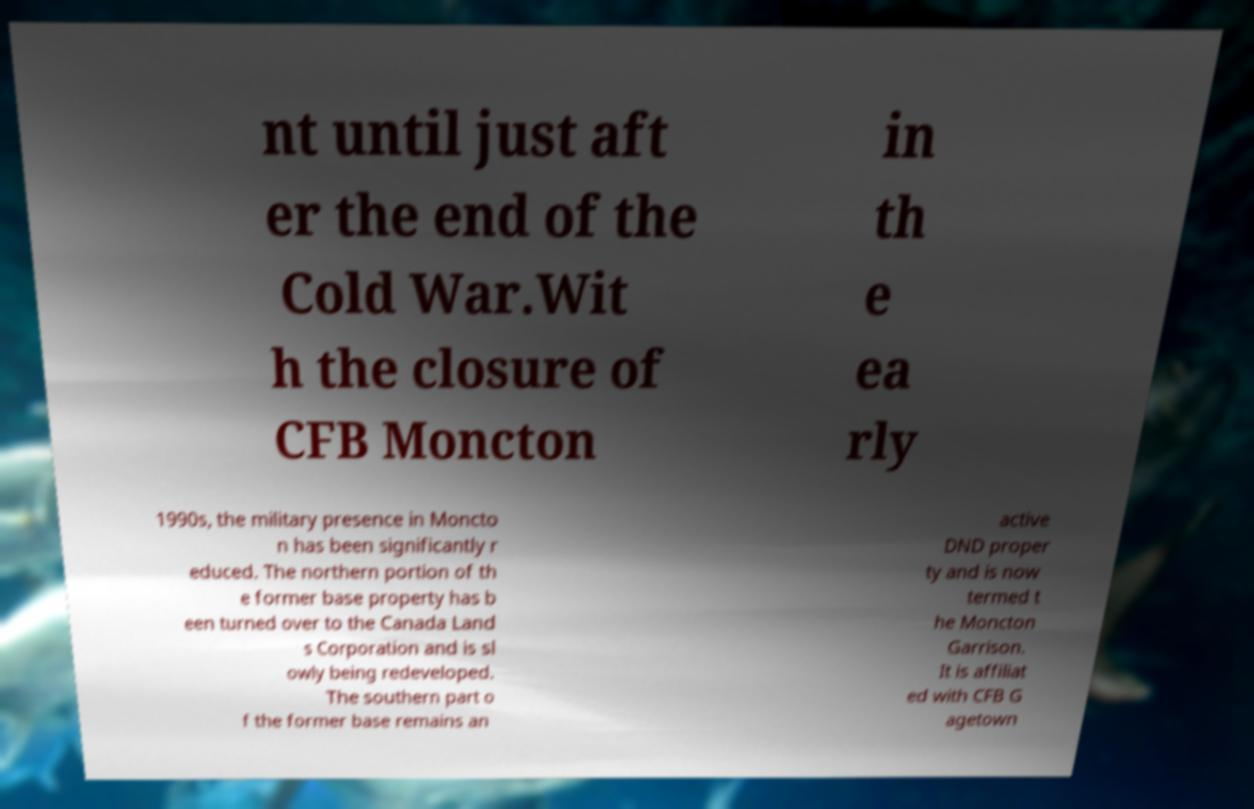Please identify and transcribe the text found in this image. nt until just aft er the end of the Cold War.Wit h the closure of CFB Moncton in th e ea rly 1990s, the military presence in Moncto n has been significantly r educed. The northern portion of th e former base property has b een turned over to the Canada Land s Corporation and is sl owly being redeveloped. The southern part o f the former base remains an active DND proper ty and is now termed t he Moncton Garrison. It is affiliat ed with CFB G agetown 